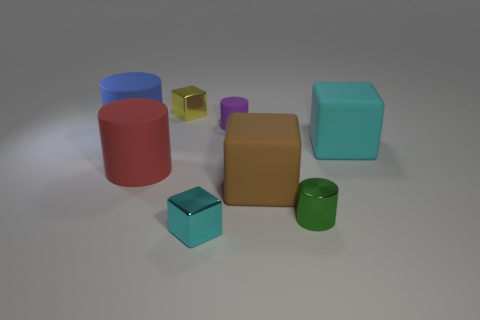The small object that is both in front of the small yellow cube and behind the blue matte object has what shape?
Your response must be concise. Cylinder. What number of blue objects are behind the cyan cube that is behind the big red object?
Provide a short and direct response. 1. Are there any other things that have the same material as the blue thing?
Provide a short and direct response. Yes. How many things are either cyan things that are in front of the small green shiny object or tiny brown metallic cylinders?
Offer a terse response. 1. What is the size of the metallic block that is on the right side of the small yellow block?
Provide a short and direct response. Small. What material is the small green cylinder?
Your answer should be compact. Metal. What is the shape of the cyan object behind the metallic block that is in front of the yellow metal cube?
Make the answer very short. Cube. What number of other objects are there of the same shape as the red object?
Ensure brevity in your answer.  3. There is a purple rubber cylinder; are there any large brown matte objects left of it?
Your answer should be compact. No. What color is the tiny matte thing?
Offer a terse response. Purple. 